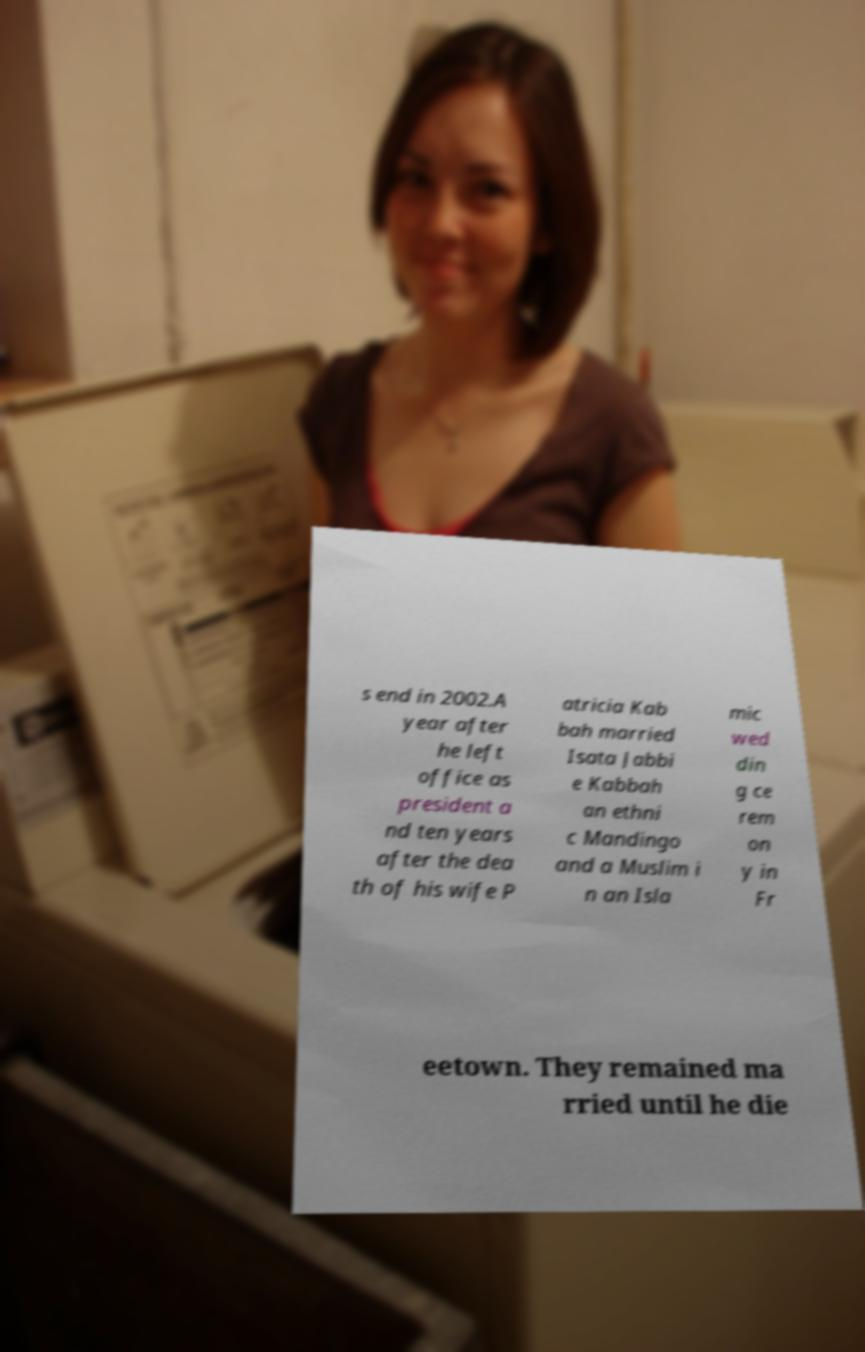There's text embedded in this image that I need extracted. Can you transcribe it verbatim? s end in 2002.A year after he left office as president a nd ten years after the dea th of his wife P atricia Kab bah married Isata Jabbi e Kabbah an ethni c Mandingo and a Muslim i n an Isla mic wed din g ce rem on y in Fr eetown. They remained ma rried until he die 